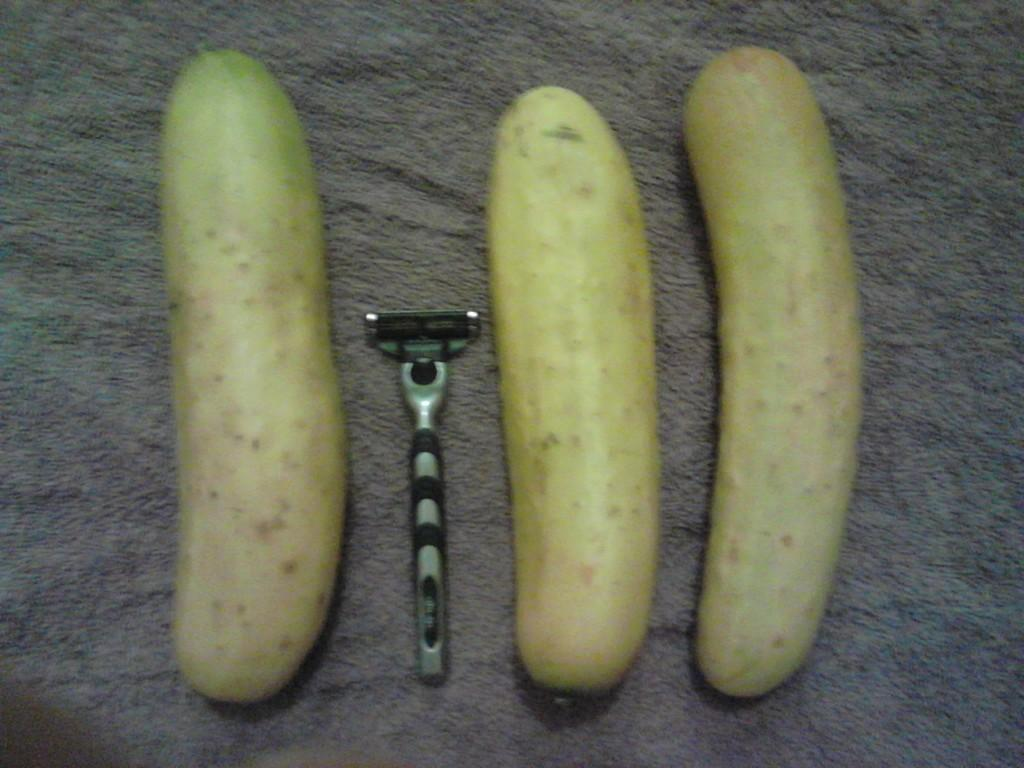How many cucumbers are visible in the image? There are three cucumbers in the image. What other object can be seen in the image? There is a razor in the image. Where are the cucumbers and razor located? The cucumbers and razor are on a platform. What type of bulb is used to light up the area where the cucumbers and razor are located? There is no bulb present in the image; it only shows cucumbers, a razor, and a platform. Is there a farmer in the image tending to the cucumbers? There is no farmer present in the image; it only shows cucumbers, a razor, and a platform. 